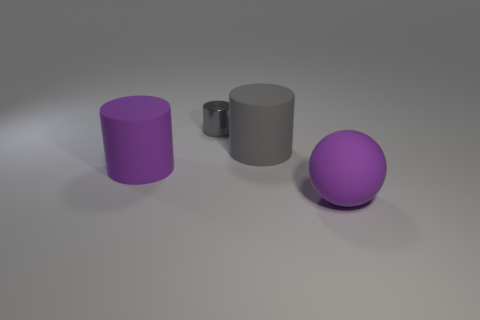Add 4 tiny green things. How many objects exist? 8 Subtract all cylinders. How many objects are left? 1 Subtract 0 red blocks. How many objects are left? 4 Subtract all matte balls. Subtract all large purple rubber objects. How many objects are left? 1 Add 4 small metal objects. How many small metal objects are left? 5 Add 4 tiny gray cylinders. How many tiny gray cylinders exist? 5 